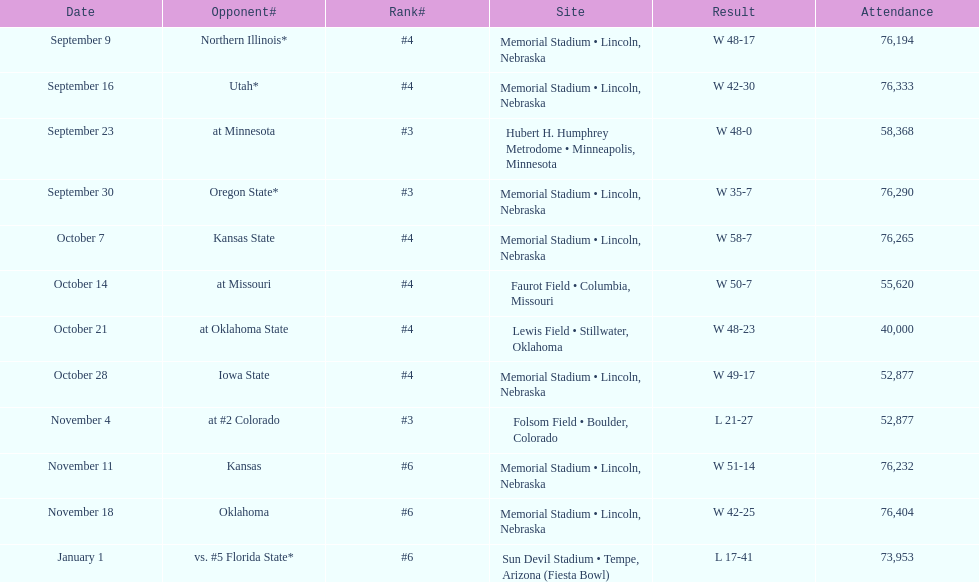Can you provide the total number of attendees at the oregon state game? 76,290. 